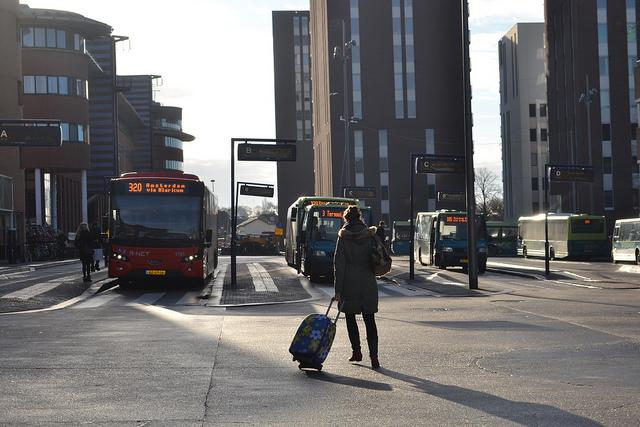What activity is the woman participating in? travel 